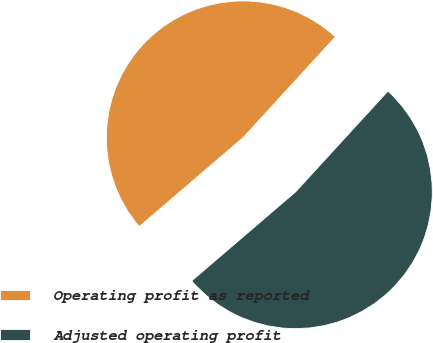<chart> <loc_0><loc_0><loc_500><loc_500><pie_chart><fcel>Operating profit as reported<fcel>Adjusted operating profit<nl><fcel>48.08%<fcel>51.92%<nl></chart> 